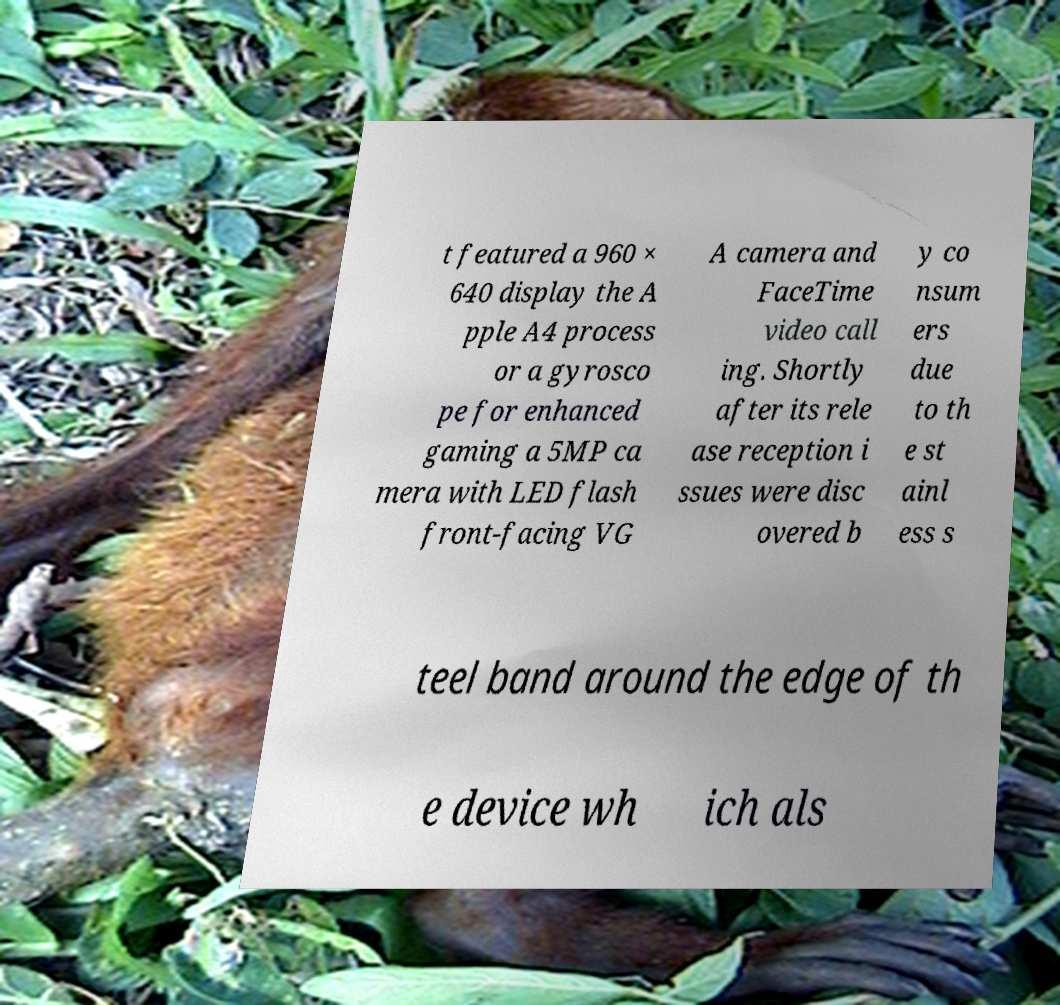Please identify and transcribe the text found in this image. t featured a 960 × 640 display the A pple A4 process or a gyrosco pe for enhanced gaming a 5MP ca mera with LED flash front-facing VG A camera and FaceTime video call ing. Shortly after its rele ase reception i ssues were disc overed b y co nsum ers due to th e st ainl ess s teel band around the edge of th e device wh ich als 